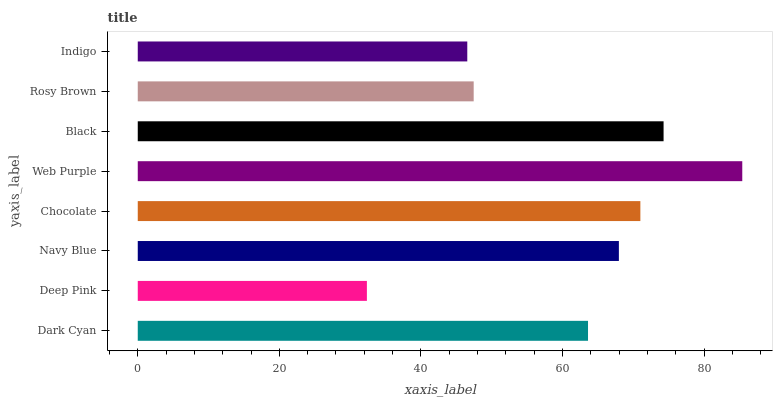Is Deep Pink the minimum?
Answer yes or no. Yes. Is Web Purple the maximum?
Answer yes or no. Yes. Is Navy Blue the minimum?
Answer yes or no. No. Is Navy Blue the maximum?
Answer yes or no. No. Is Navy Blue greater than Deep Pink?
Answer yes or no. Yes. Is Deep Pink less than Navy Blue?
Answer yes or no. Yes. Is Deep Pink greater than Navy Blue?
Answer yes or no. No. Is Navy Blue less than Deep Pink?
Answer yes or no. No. Is Navy Blue the high median?
Answer yes or no. Yes. Is Dark Cyan the low median?
Answer yes or no. Yes. Is Rosy Brown the high median?
Answer yes or no. No. Is Black the low median?
Answer yes or no. No. 